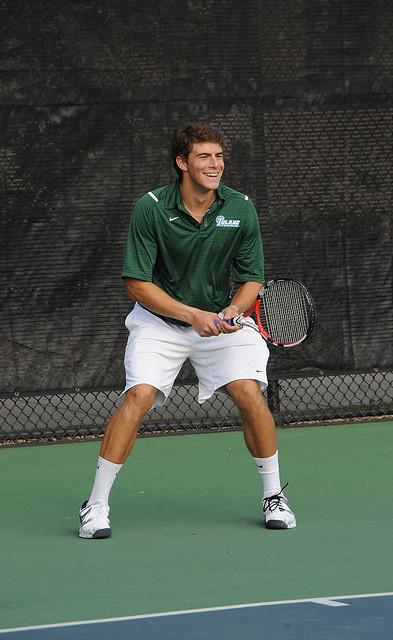Which way is the man leaning?
Write a very short answer. Forward. Does the person appear to be happy?
Short answer required. Yes. Is the man wearing glasses?
Short answer required. No. Did the player just lose the match?
Concise answer only. No. What color is the man's shirt?
Short answer required. Green. Is the man swinging the tennis racket, or is it stationary?
Concise answer only. Stationary. IS this person wearing a hat?
Write a very short answer. No. Does the man have a stripe on his shorts?
Answer briefly. No. Is this person likely to be actually playing tennis?
Quick response, please. Yes. Is it a sunny day?
Be succinct. Yes. Is he wearing a headband?
Be succinct. No. Is tennis a healthy way to get into shape?
Concise answer only. Yes. Are the man's eyes closed?
Give a very brief answer. No. Is this man on the ground?
Write a very short answer. Yes. What color is the kid's shirt?
Concise answer only. Green. What colors are in the man's shirt besides white?
Write a very short answer. Green. What color is the court?
Short answer required. Green. What surface is the court?
Give a very brief answer. Clay. How many people are pictured?
Answer briefly. 1. 